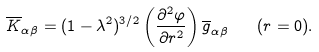Convert formula to latex. <formula><loc_0><loc_0><loc_500><loc_500>\overline { K } _ { \alpha \beta } = ( 1 - \lambda ^ { 2 } ) ^ { 3 / 2 } \left ( \frac { \partial ^ { 2 } \varphi } { \partial r ^ { 2 } } \right ) \overline { g } _ { \alpha \beta } \quad ( r = 0 ) .</formula> 